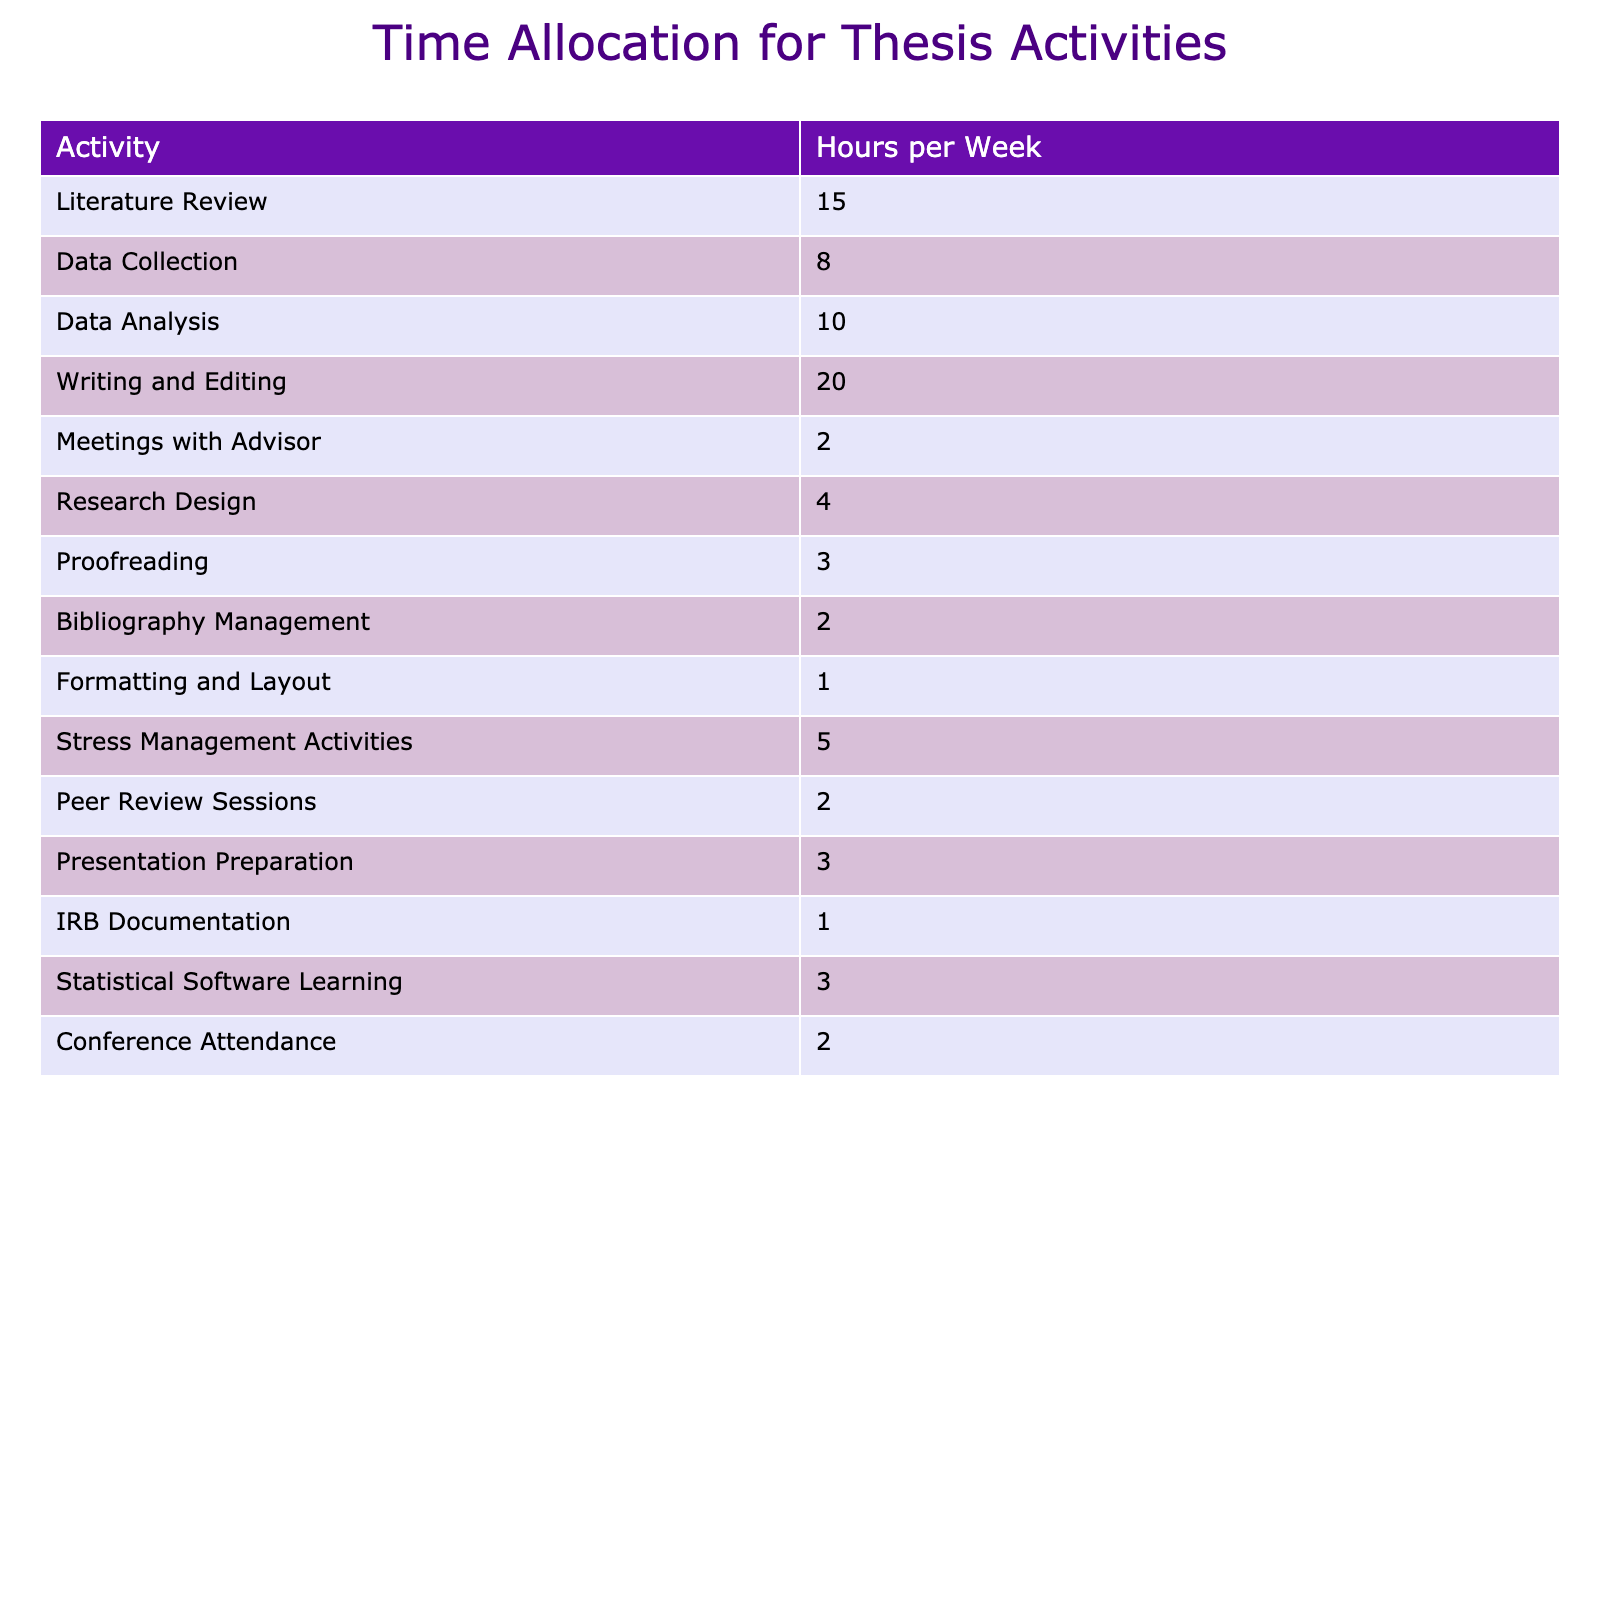What activity requires the most time per week? The activity requiring the most time can be identified by looking for the highest value in the table. Writing and Editing has 20 hours per week, which is the highest among all activities.
Answer: Writing and Editing How many hours are allocated to Literature Review? Literature Review is listed in the table, and the corresponding value shows that it takes 15 hours per week.
Answer: 15 What are the total hours per week spent on stress management activities? Stress Management Activities specifically shows 5 hours in the table. So, no additional calculations are needed; the value is simply retrieved.
Answer: 5 How much more time is spent on Data Analysis compared to IRB Documentation? To find the difference, we need to find the values for Data Analysis (10 hours) and IRB Documentation (1 hour) in the table. The difference is calculated as 10 - 1 = 9 hours.
Answer: 9 What percentage of the total weekly hours (sum of all activities) is spent on Writing and Editing? The total sum of hours for all activities is calculated by adding up each hour per week (15 + 8 + 10 + 20 + 2 + 4 + 3 + 2 + 1 + 5 + 2 + 3 + 1 + 3 + 2), which equals 82 hours. Writing and Editing is 20 hours. The percentage is (20/82) * 100 ≈ 24.39%.
Answer: Approximately 24.39% Is the time allocated for Meetings with Advisor more than that for Formatting and Layout? Meetings with Advisor takes 2 hours and Formatting and Layout takes only 1 hour, allowing us to see that Meetings with Advisor has more time allocated. Thus, the statement is true.
Answer: Yes Which two activities combined take up more time, Data Collection and Statistical Software Learning, or Meetings with Advisor and Formatting and Layout? First, we find the hours for each pair: Data Collection (8) + Statistical Software Learning (3) = 11 hours and Meetings with Advisor (2) + Formatting and Layout (1) = 3 hours. Since 11 hours is greater than 3 hours, it confirms that the first pair combined takes up more time.
Answer: Data Collection and Statistical Software Learning What is the average time spent on Proofreading and Presentation Preparation? Both Proofreading takes 3 hours and Presentation Preparation takes 3 hours as listed in the table. The average is calculated by (3 + 3) / 2 = 3 hours.
Answer: 3 